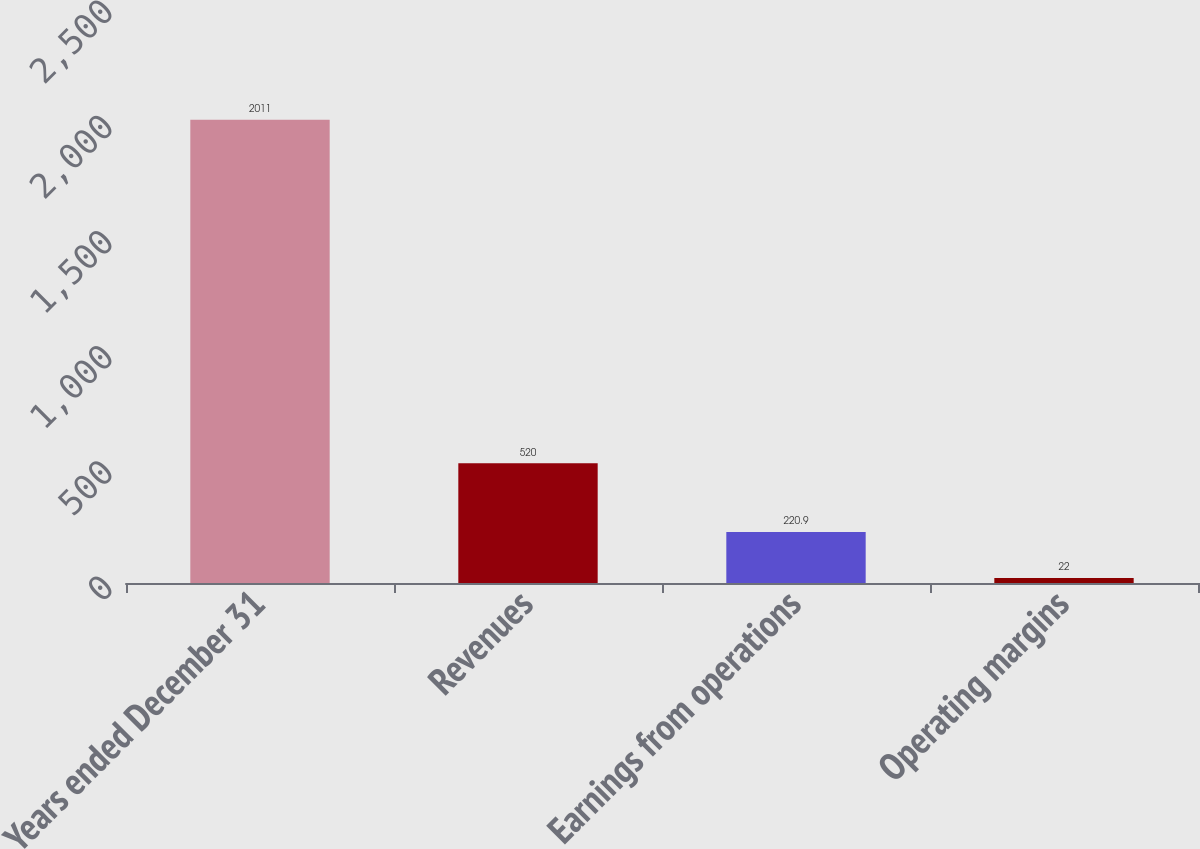Convert chart to OTSL. <chart><loc_0><loc_0><loc_500><loc_500><bar_chart><fcel>Years ended December 31<fcel>Revenues<fcel>Earnings from operations<fcel>Operating margins<nl><fcel>2011<fcel>520<fcel>220.9<fcel>22<nl></chart> 